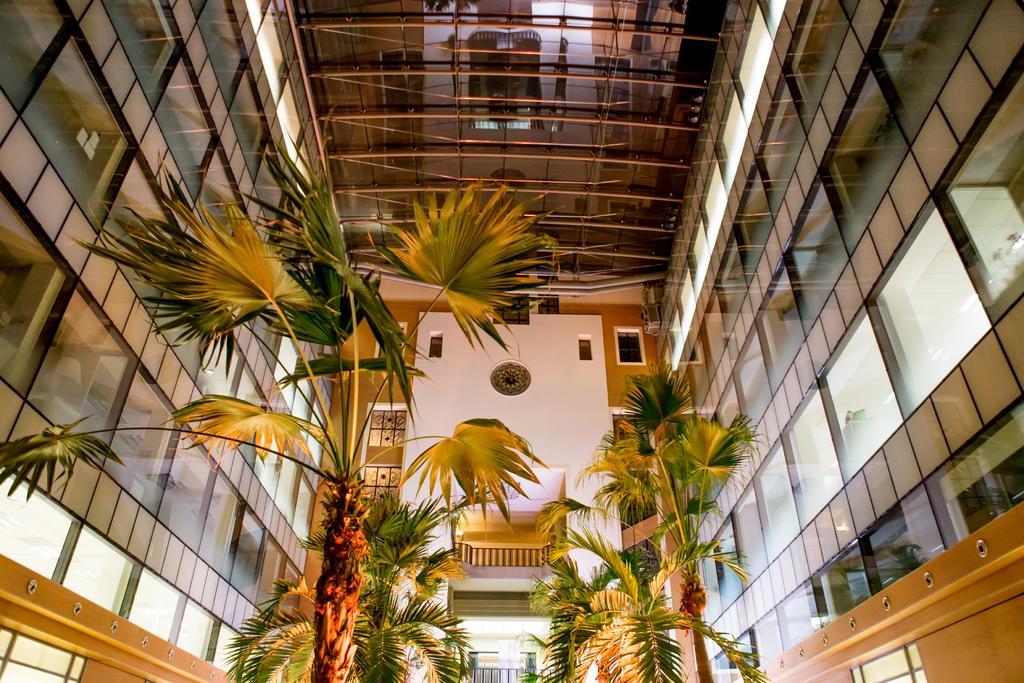How would you summarize this image in a sentence or two? In this image we can see trees and the glass wall. At the top of the image, the roof is there. In the middle of the image we can see balcony and white color wall. 